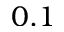Convert formula to latex. <formula><loc_0><loc_0><loc_500><loc_500>0 . 1</formula> 